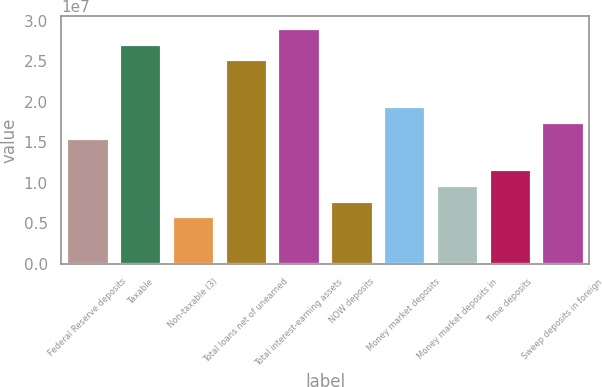Convert chart to OTSL. <chart><loc_0><loc_0><loc_500><loc_500><bar_chart><fcel>Federal Reserve deposits<fcel>Taxable<fcel>Non-taxable (3)<fcel>Total loans net of unearned<fcel>Total interest-earning assets<fcel>NOW deposits<fcel>Money market deposits<fcel>Money market deposits in<fcel>Time deposits<fcel>Sweep deposits in foreign<nl><fcel>1.55601e+07<fcel>2.71887e+07<fcel>5.86959e+06<fcel>2.52506e+07<fcel>2.91268e+07<fcel>7.80769e+06<fcel>1.94363e+07<fcel>9.74579e+06<fcel>1.16839e+07<fcel>1.74982e+07<nl></chart> 